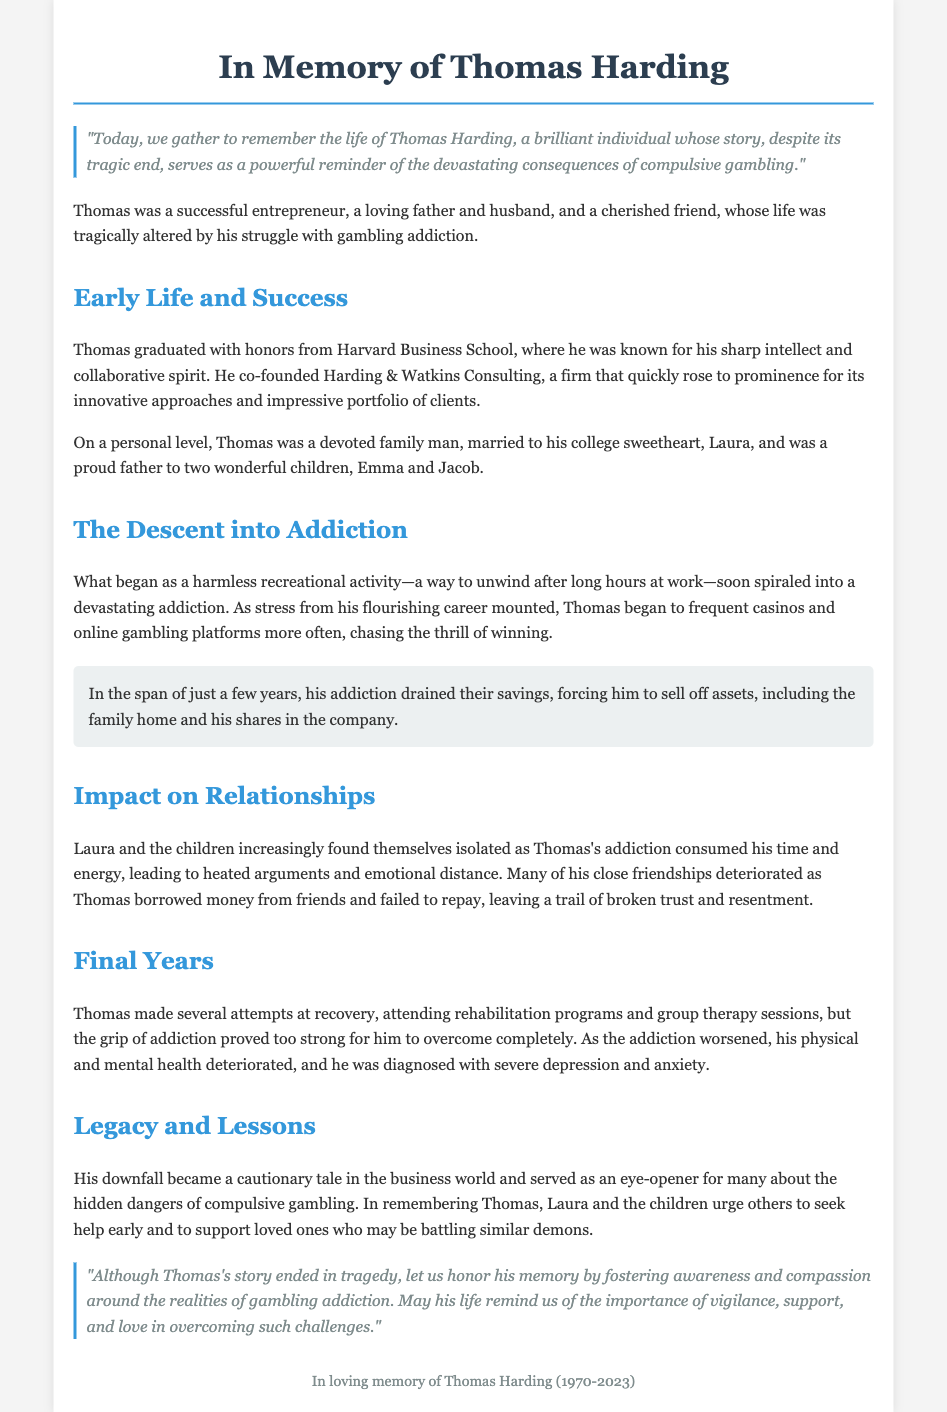What was Thomas Harding's profession? Thomas Harding was a co-founder of Harding & Watkins Consulting, indicating he was an entrepreneur.
Answer: entrepreneur What university did Thomas graduate from? The document states that Thomas graduated with honors from Harvard Business School.
Answer: Harvard Business School How many children did Thomas have? The text mentions that he was a proud father to two wonderful children, Emma and Jacob, indicating he had two children.
Answer: two What caused the breakdown of Thomas's marriage? The document highlights that emotional distance and heated arguments due to Thomas's addiction led to a breakdown in his marriage with Laura.
Answer: addiction What mental health issues was Thomas diagnosed with? The document specifies that Thomas was diagnosed with severe depression and anxiety due to his worsening addiction.
Answer: severe depression and anxiety What event signifies the peak of Thomas's success? The rising prominence of his consulting firm, Harding & Watkins Consulting, signifies the peak of his success.
Answer: Harding & Watkins Consulting What lesson do Laura and the children hope to impart by remembering Thomas? They urge others to seek help early and support loved ones battling similar demons, highlighting the importance of awareness of gambling addiction.
Answer: seek help early What year was Thomas born? The document indicates Thomas was born in 1970, as mentioned in the footer section.
Answer: 1970 